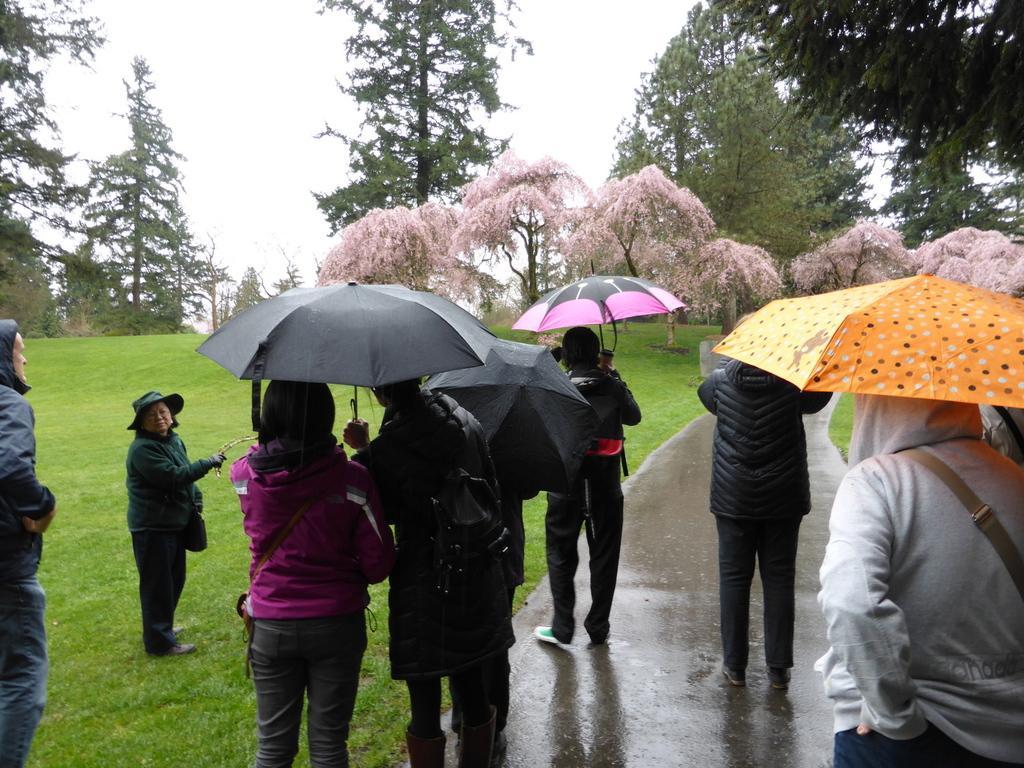Please provide a concise description of this image. In this image there are a few people standing on the road and they are holding an umbrella in their hands and few are standing on the surface of the grass. In the background there are trees and the sky. 